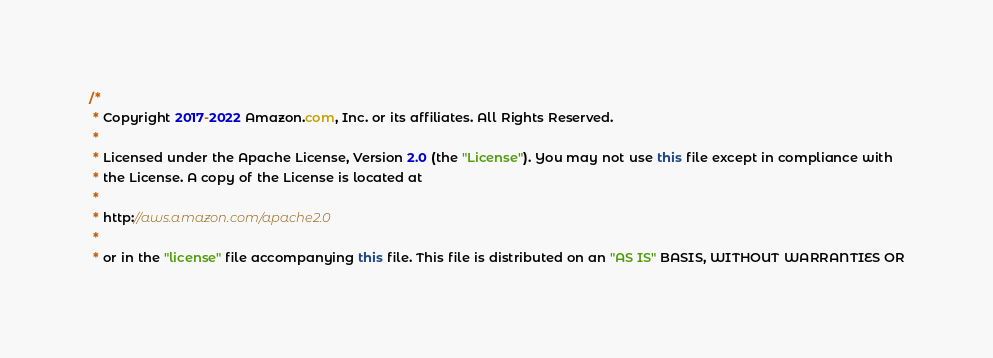Convert code to text. <code><loc_0><loc_0><loc_500><loc_500><_Java_>/*
 * Copyright 2017-2022 Amazon.com, Inc. or its affiliates. All Rights Reserved.
 * 
 * Licensed under the Apache License, Version 2.0 (the "License"). You may not use this file except in compliance with
 * the License. A copy of the License is located at
 * 
 * http://aws.amazon.com/apache2.0
 * 
 * or in the "license" file accompanying this file. This file is distributed on an "AS IS" BASIS, WITHOUT WARRANTIES OR</code> 